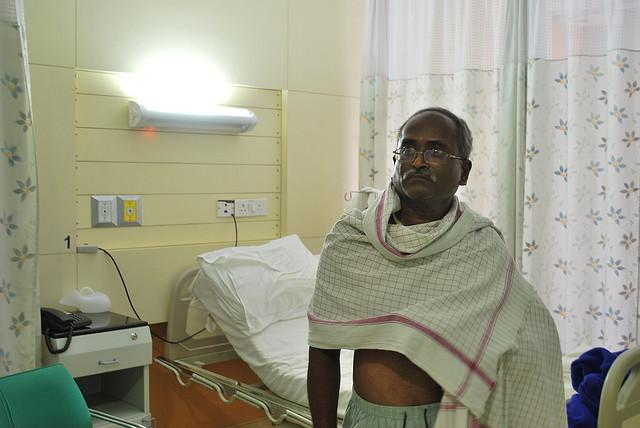This man looks most similar to what historical figure? gandhi 